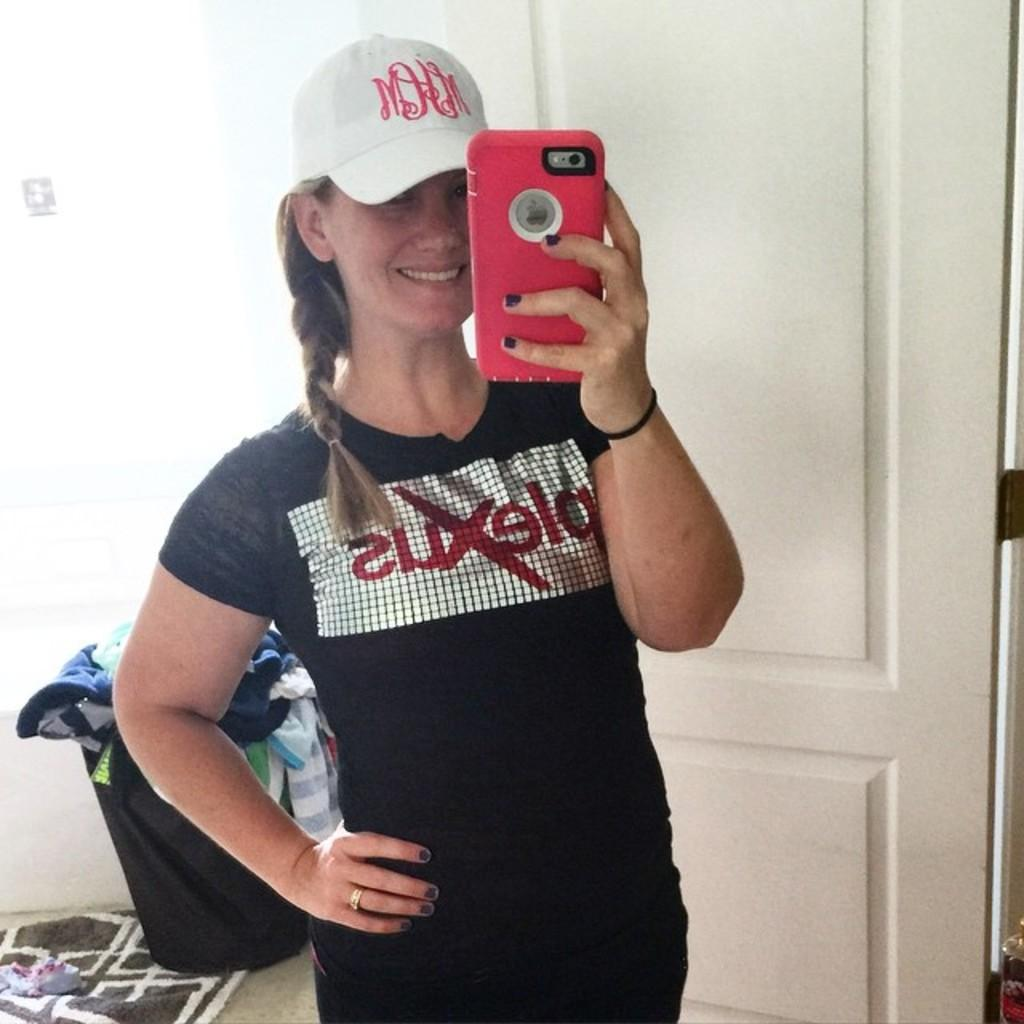What is the lady in the image wearing? The lady is wearing a black dress and a cap. What is the lady holding in the image? The lady is holding a mobile. What can be seen in the background of the image? There is a door, a laundry bin with dresses inside, and a carpet in the background of the image. What type of pies can be seen on the carpet in the image? There are no pies present in the image; the carpet is empty. 